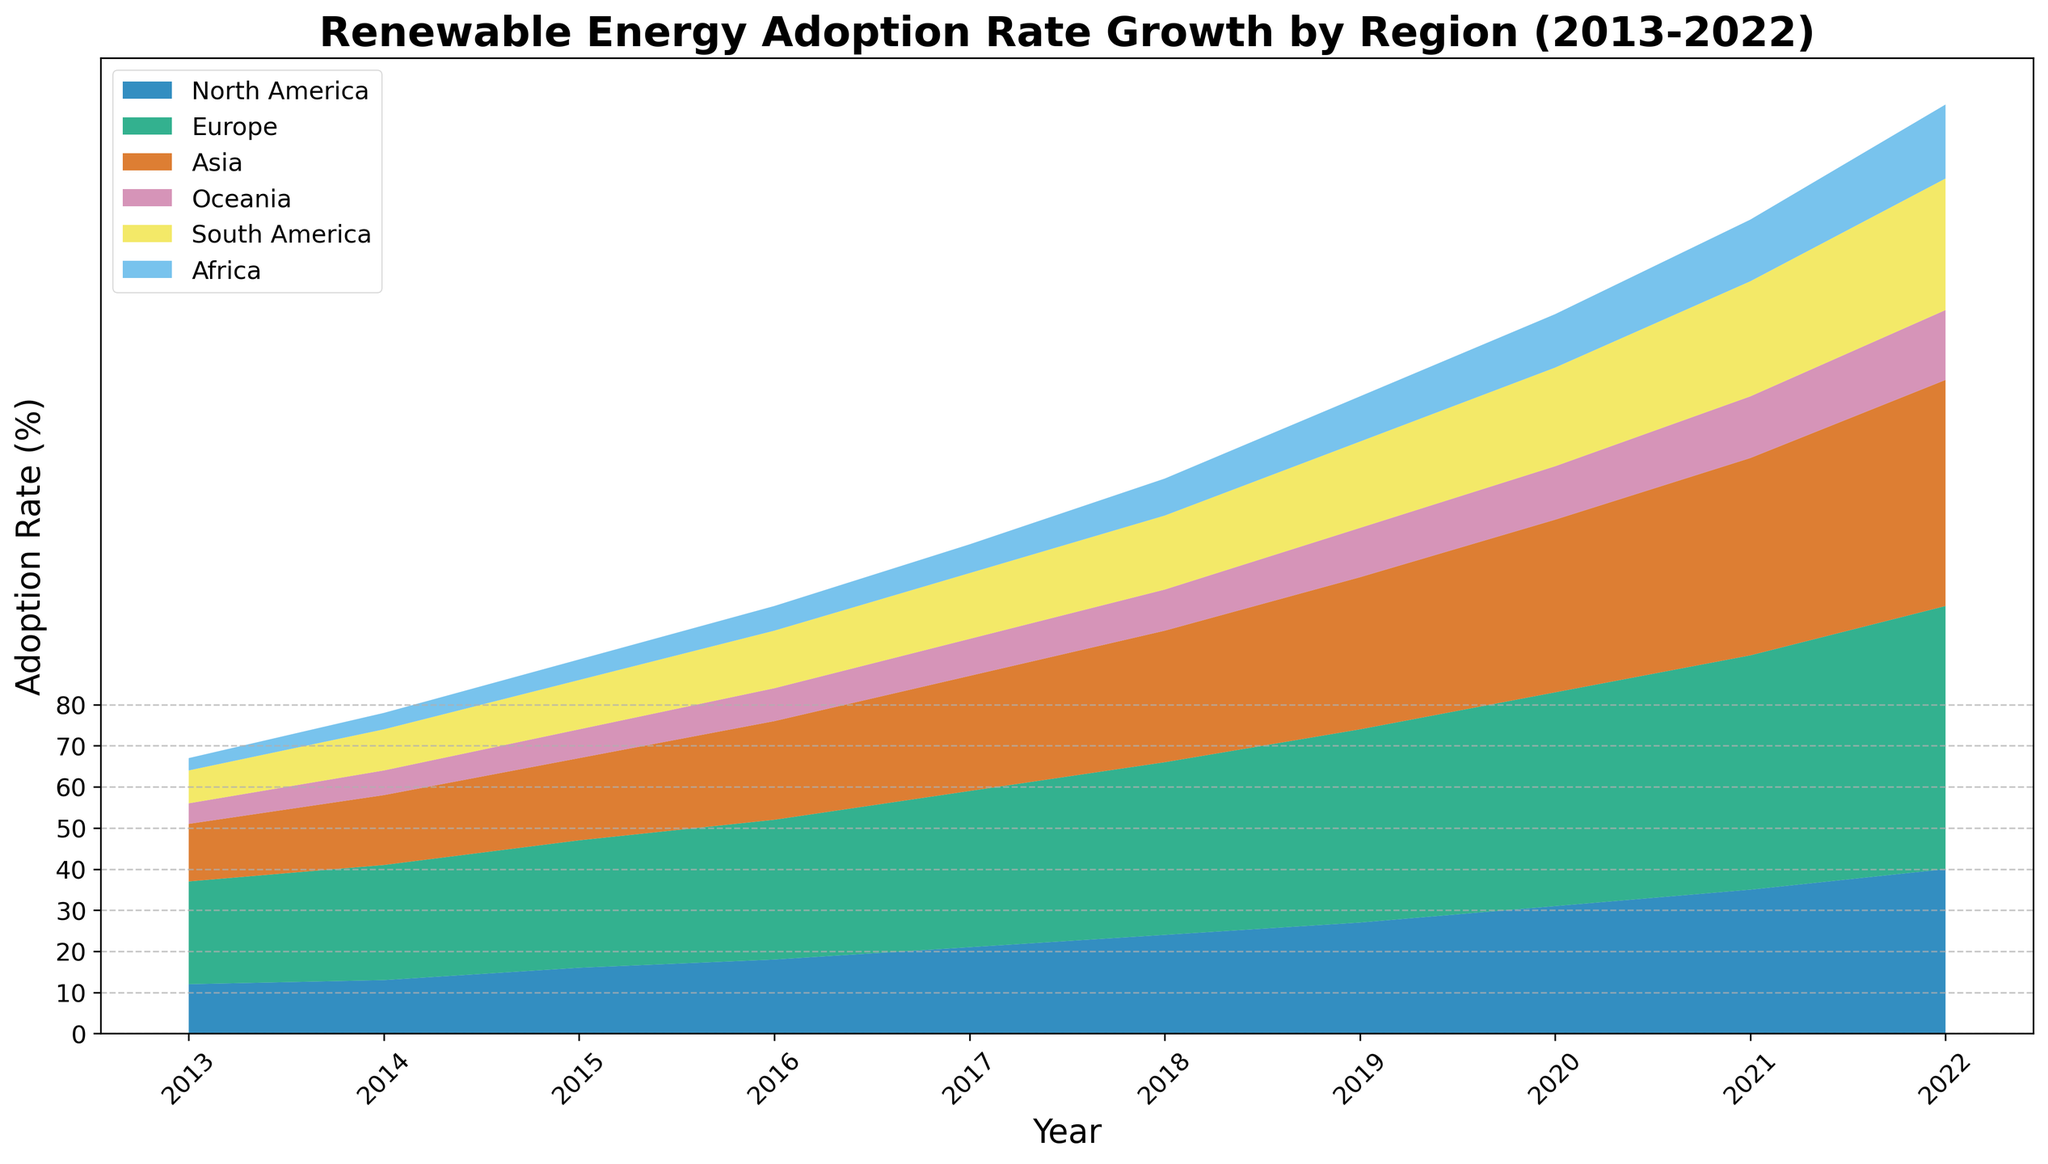How has the renewable energy adoption rate in Europe changed from 2013 to 2022? Look at the figure, identify the values for Europe in 2013 and 2022, and note the increase. Europe’s rate goes from 25% in 2013 to 64% in 2022. The change is 64% - 25% = 39%.
Answer: 39% Which region had a higher renewable energy adoption rate in 2022: North America or Asia? Compare the height of the area segments for North America and Asia in 2022 on the figure. North America is at 40% and Asia is at 55%.
Answer: Asia What is the combined adoption rate of North America and South America in 2020? Find the values for North America and South America in 2020 (31% for North America and 24% for South America), then add them up. 31% + 24% = 55%.
Answer: 55% How does the growth in renewable energy adoption in Africa compare to Oceania from 2013 to 2022? Look at the figure to find the values for Africa and Oceania in 2013 and 2022. For Africa, it’s 3% in 2013 and 18% in 2022, a growth of 15%. For Oceania, it’s 5% in 2013 and 17% in 2022, a growth of 12%.
Answer: Africa grew by 15%; Oceania grew by 12% In which year did both Europe and Asia show an equal increase in their renewable energy adoption rates? Identify the adoption rates for both Europe and Asia for each year on the plot and calculate their year-over-year differences, finding where these differences are equ(al). Both had an increase of 4% from 2020 to 2021 (Europe 52 to 57, Asia 42 to 48).
Answer: 2021 What's the total adoption rate of renewable energy across all regions in 2018? Sum the renewable energy adoption rates across all regions for 2018: North America (24%), Europe (42%), Asia (32%), Oceania (10%), South America (18%), and Africa (9%). 24% + 42% + 32% + 10% + 18% + 9% = 135%.
Answer: 135% Which region shows the steepest slope in renewable energy adoption between 2019 and 2022? Compare the slopes representing the increase in adoption rate for all regions between 2019 and 2022. Europe shows the steepest increase, from 47% to 64%, an increase of 17%.
Answer: Europe How did the renewable energy adoption rate in South America change from 2013 to 2017? Look at the figure and identify values for South America in 2013 and 2017 (8% in 2013 and 16% in 2017). The change is 16% - 8% = 8%.
Answer: 8% By how much did Asia's renewable energy adoption rate increase from 2014 to 2019? Identify Asia's adoption rates in 2014 and 2019 (17% in 2014 and 37% in 2019) and calculate the difference. 37% - 17% = 20%.
Answer: 20% Which region had the most consistent (least variable) increase in renewable energy adoption from 2013 to 2022? Visual estimation from the plot shows that North America had a relatively consistent slope without large fluctuations compared to other regions.
Answer: North America 